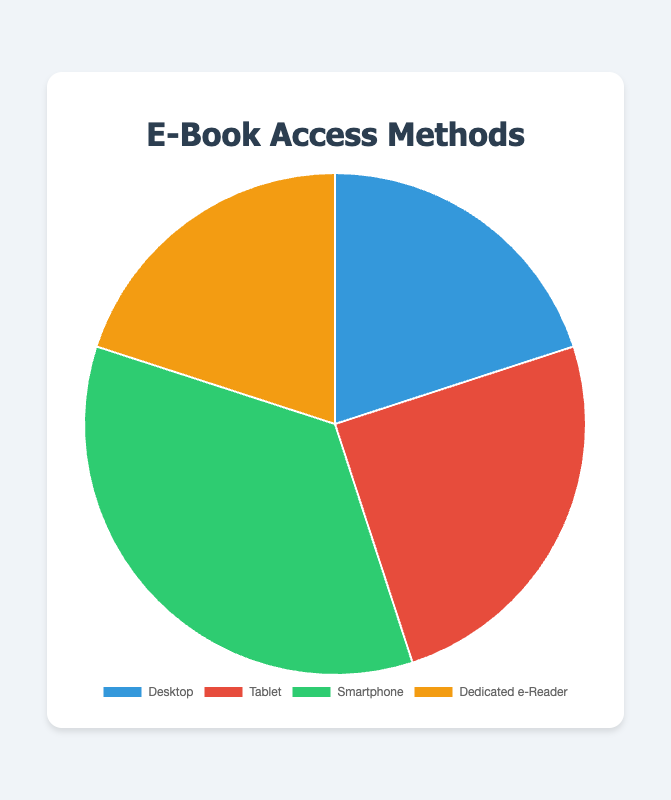Which method has the highest percentage of users? Look at the pie chart, identify the segment with the largest proportion. Smartphone has the highest value at 35%.
Answer: Smartphone What is the combined percentage of users who access e-books via Desktop and Dedicated e-Reader? Identify the segments for Desktop and Dedicated e-Reader. Desktop has 20% and Dedicated e-Reader has 20%. Add them up: 20% + 20% = 40%.
Answer: 40% How many more percentage points does Smartphone have compared to Tablet? Identify the percentages for Smartphone and Tablet. Smartphone has 35% and Tablet has 25%. Calculate the difference: 35% - 25% = 10%.
Answer: 10% Which methods have an equal percentage of users? Identify segments with identical percentages. Desktop and Dedicated e-Reader both have 20%.
Answer: Desktop and Dedicated e-Reader Which color represents the Tablet method in the pie chart? Visually identify the color associated with the Tablet segment in the chart. Tablet's color is red.
Answer: Red Find the average percentage of users across all four methods. Sum up all percentages: 20% (Desktop) + 25% (Tablet) + 35% (Smartphone) + 20% (Dedicated e-Reader) = 100%. Divide by 4 methods: 100% / 4 = 25%.
Answer: 25% Which method has the lowest percentage of users? Identify the segment with the smallest proportion. Desktop and Dedicated e-Reader have the lowest values at 20% each.
Answer: Desktop and Dedicated e-Reader What is the difference in the percentage of users between Tablet and Desktop methods? Identify the percentages for Tablet and Desktop. Tablet has 25% and Desktop has 20%. Calculate the difference: 25% - 20% = 5%.
Answer: 5% If 5% of Desktop users switched to using a Tablet, what would the new percentages be for Desktop and Tablet? Current Desktop is 20%, Tablet is 25%. Reduce Desktop by 5%: 20% - 5% = 15%. Increase Tablet by 5%: 25% + 5% = 30%.
Answer: Desktop: 15%, Tablet: 30% How much more popular is using a Smartphone compared to a Dedicated e-Reader? Identify the percentages for Smartphone and Dedicated e-Reader. Smartphone has 35% and Dedicated e-Reader has 20%. Calculate the difference: 35% - 20% = 15%.
Answer: 15% 